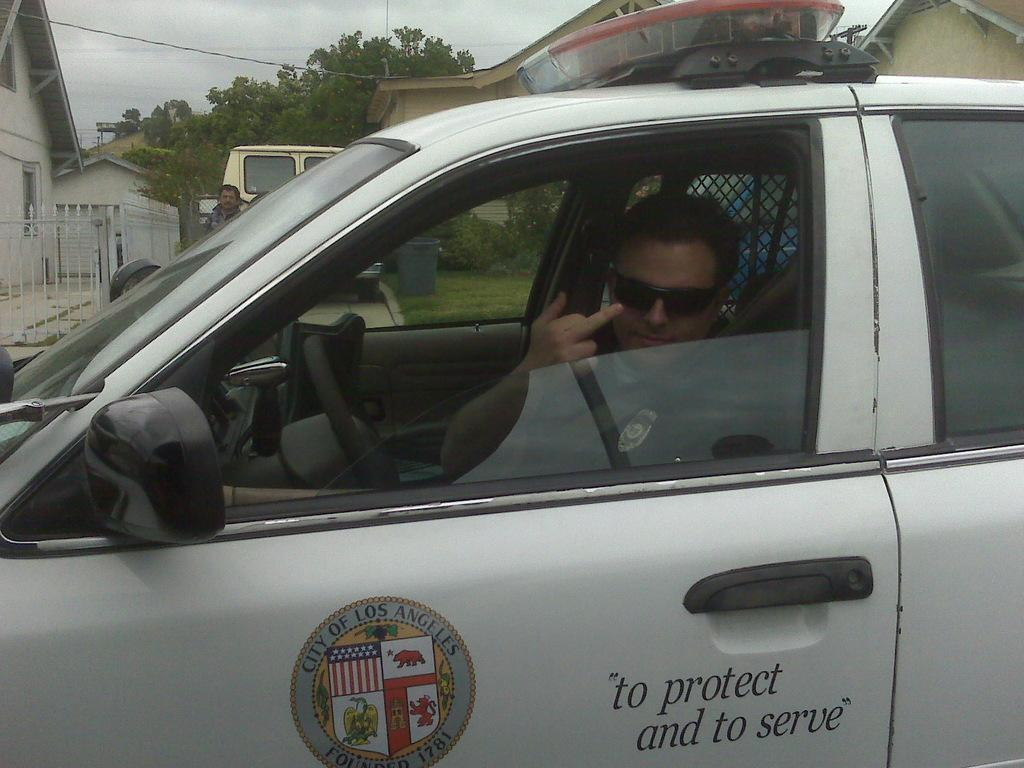What is the man in the image doing? The man is sitting on a white car in the image. Can you describe the other person in the image? There is another man standing in the background. What other vehicle is present in the image? There is a van in the image. What can be seen on both sides of the image? There are buildings on the right and left sides of the image. What type of natural elements are visible in the image? Trees are visible in the image. What is visible at the top of the image? The sky is visible at the top of the image. Where are the pigs located in the image? There are no pigs present in the image. What type of drink is being served in the image? There is no drink present in the image, let alone eggnog. 